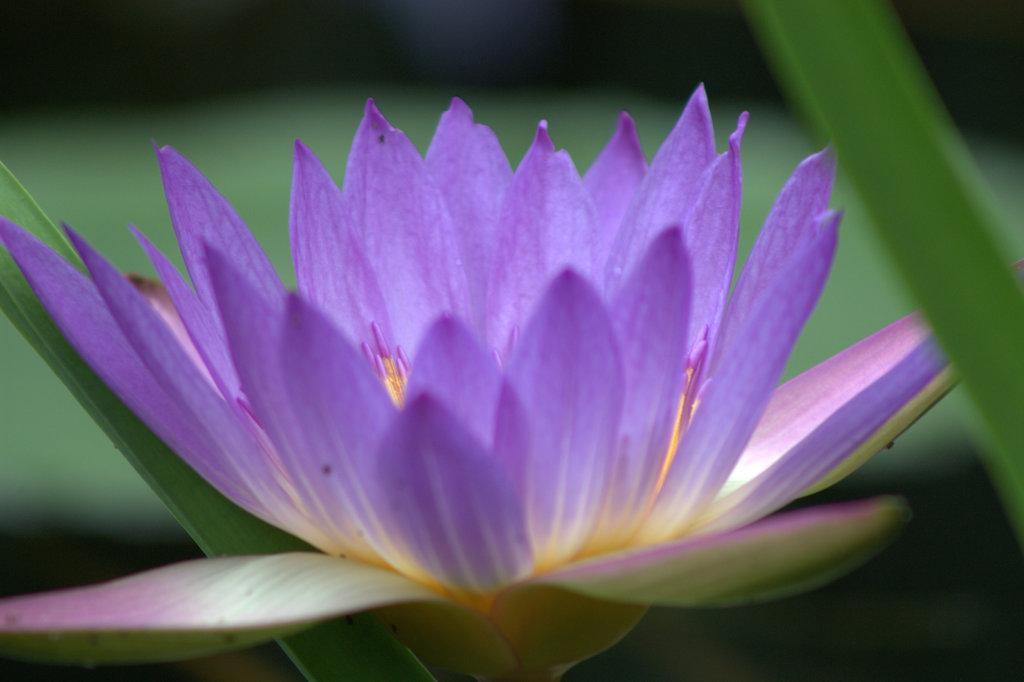What type of plant can be seen in the image? There is a flower in the image. What else is visible in the image besides the flower? There are leaves in the image. How does the flower contribute to the expansion of the forest in the image? The image does not depict a forest, and the flower's presence does not contribute to any expansion. 